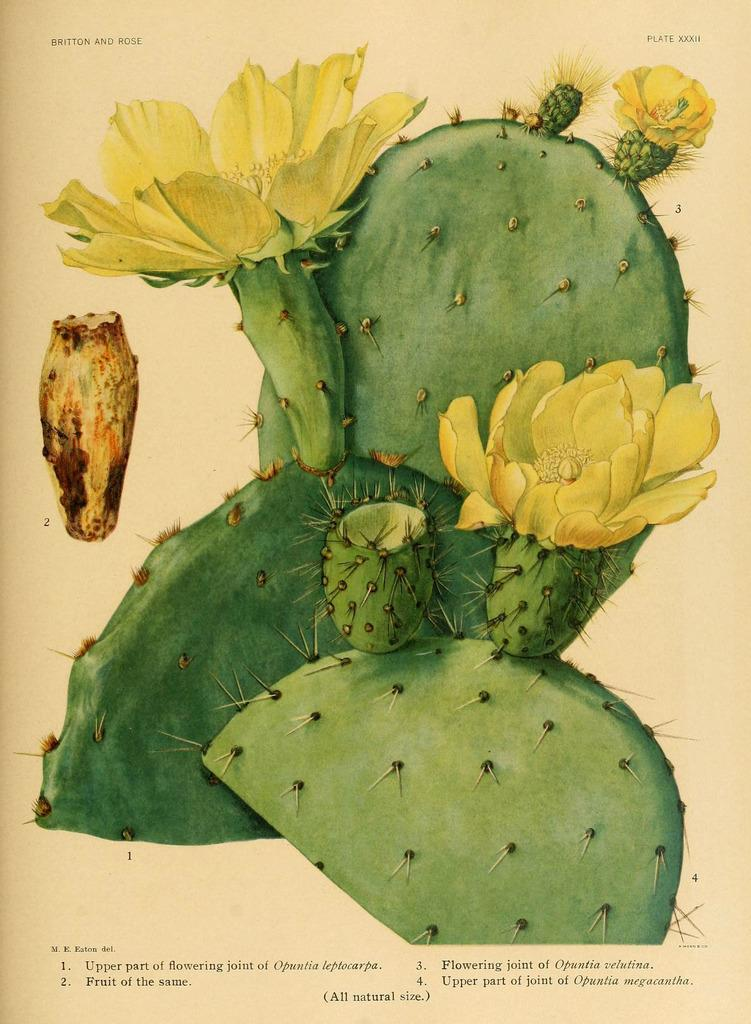What is the main subject of the poster in the image? The poster contains flowers and plants. Where is the text located on the poster? There is text at the top and bottom of the poster. What type of animal can be seen climbing the hill in the image? There is no hill or animal present in the image; it features a poster with flowers and plants. 